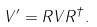Convert formula to latex. <formula><loc_0><loc_0><loc_500><loc_500>V ^ { \prime } = R V R ^ { \dagger } .</formula> 